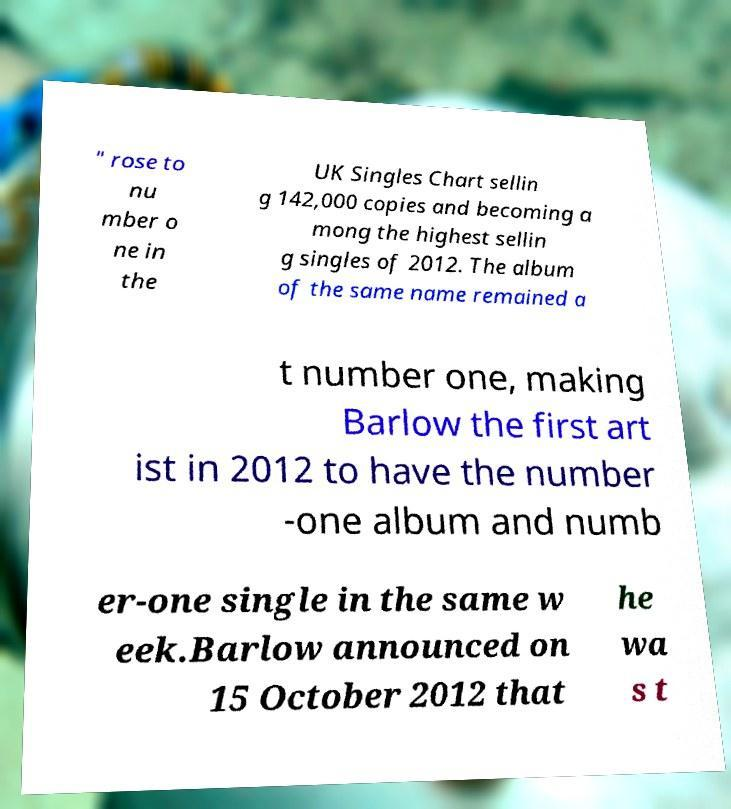Please identify and transcribe the text found in this image. " rose to nu mber o ne in the UK Singles Chart sellin g 142,000 copies and becoming a mong the highest sellin g singles of 2012. The album of the same name remained a t number one, making Barlow the first art ist in 2012 to have the number -one album and numb er-one single in the same w eek.Barlow announced on 15 October 2012 that he wa s t 